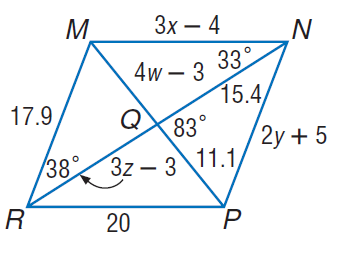Answer the mathemtical geometry problem and directly provide the correct option letter.
Question: Use parallelogram M N P R to find m \angle M Q R.
Choices: A: 83 B: 97 C: 103 D: 107 A 